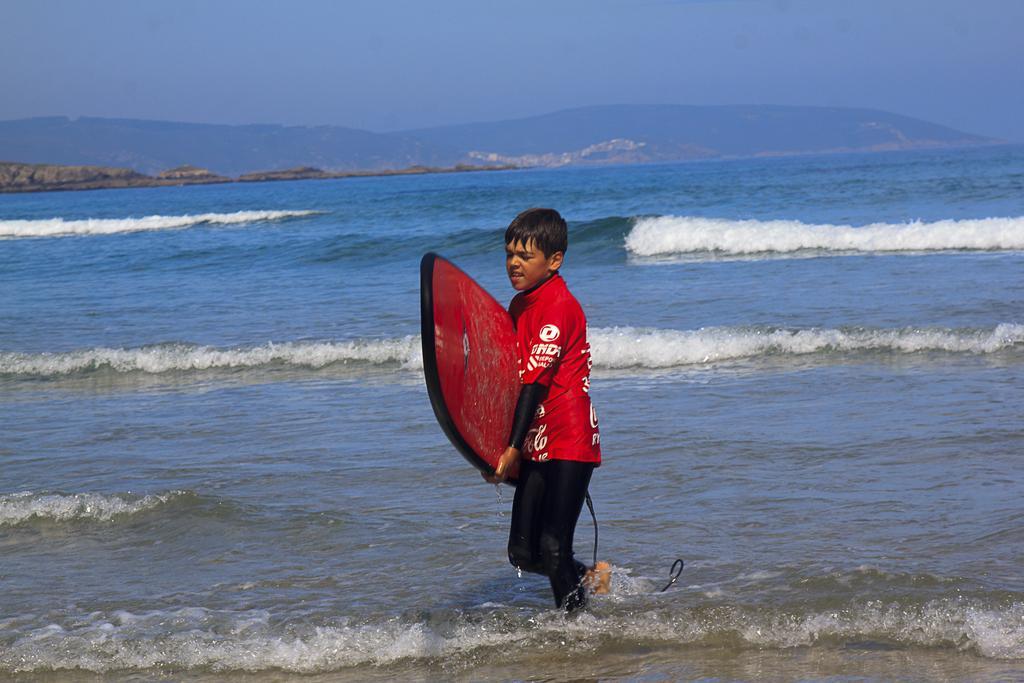Please provide a concise description of this image. In this picture there is a boy who is wearing t-shirt and trouser. He is holding a board and walking on the beach. In the back I can see the river. In the background I can see the mountains. At the top I can see the sky. 